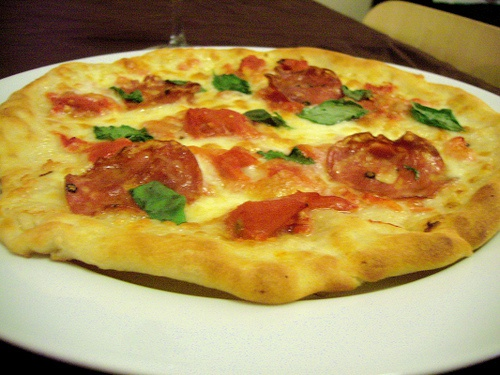Describe the objects in this image and their specific colors. I can see pizza in black, orange, red, tan, and khaki tones, dining table in black, maroon, olive, and gray tones, and wine glass in black, maroon, olive, and gray tones in this image. 